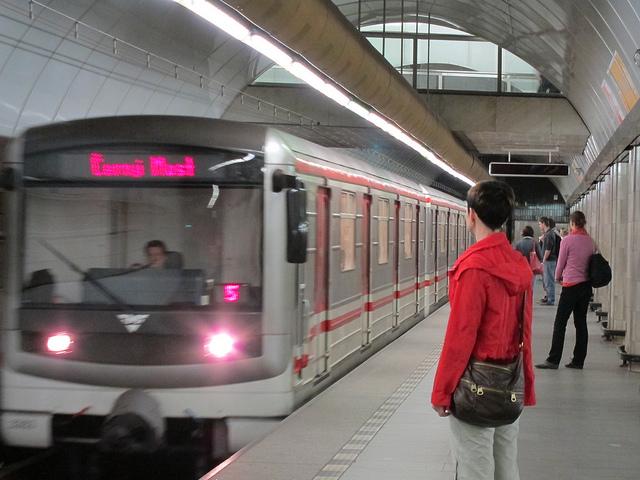What number is the train?
Short answer required. 5. What color is the jacket on the person in the front of the platform?
Concise answer only. Red. What are the people waiting for?
Short answer required. Train. 